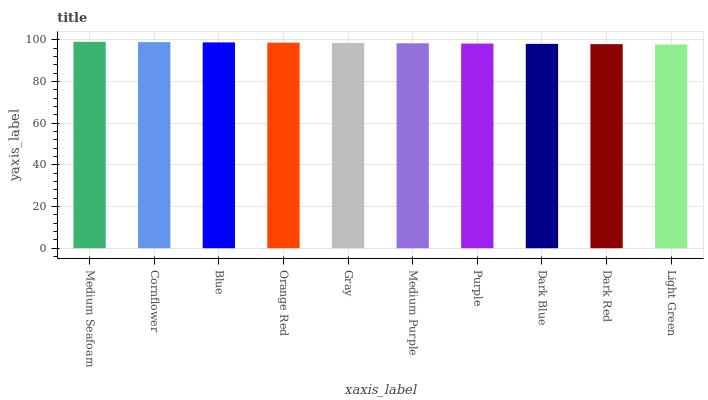Is Light Green the minimum?
Answer yes or no. Yes. Is Medium Seafoam the maximum?
Answer yes or no. Yes. Is Cornflower the minimum?
Answer yes or no. No. Is Cornflower the maximum?
Answer yes or no. No. Is Medium Seafoam greater than Cornflower?
Answer yes or no. Yes. Is Cornflower less than Medium Seafoam?
Answer yes or no. Yes. Is Cornflower greater than Medium Seafoam?
Answer yes or no. No. Is Medium Seafoam less than Cornflower?
Answer yes or no. No. Is Gray the high median?
Answer yes or no. Yes. Is Medium Purple the low median?
Answer yes or no. Yes. Is Light Green the high median?
Answer yes or no. No. Is Dark Red the low median?
Answer yes or no. No. 